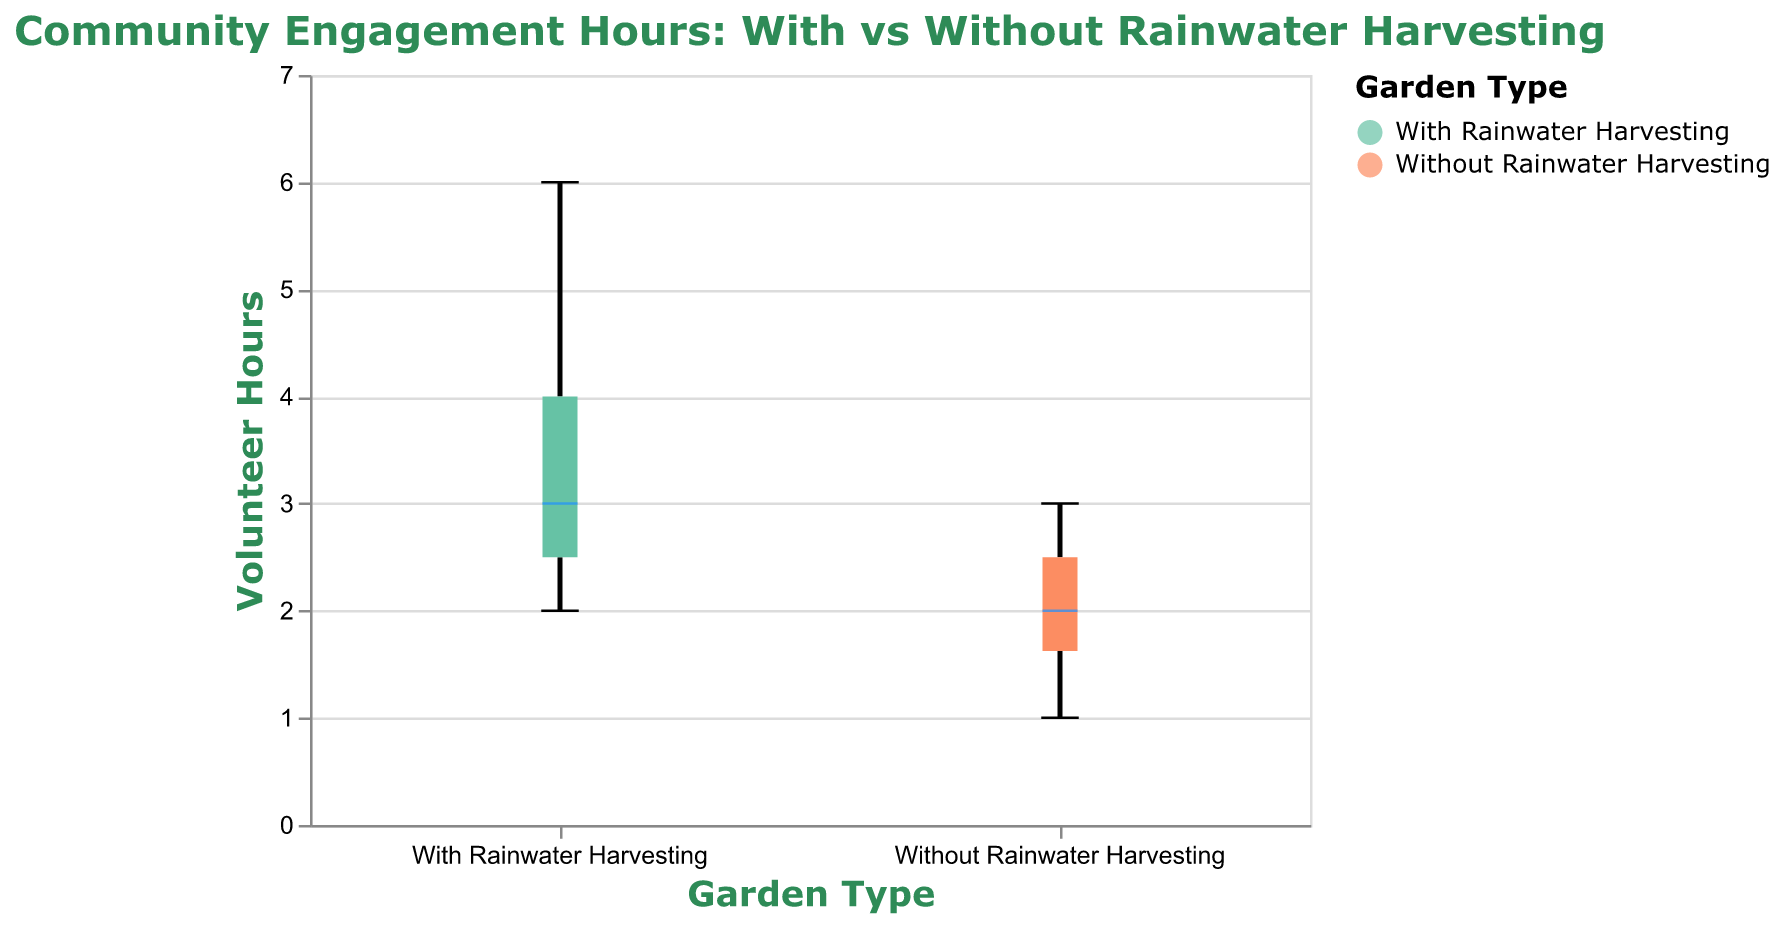What's the title of the figure? The title of the figure is displayed at the top and reads "Community Engagement Hours: With vs Without Rainwater Harvesting".
Answer: Community Engagement Hours: With vs Without Rainwater Harvesting What is the range of volunteer hours plotted on the y-axis? The y-axis limits are indicated with numerical values, with a minimum at 0 and a maximum at 7 hours.
Answer: 0 to 7 hours What is the median volunteer hours for gardens with rainwater harvesting? The median value is represented by a colored line within the box for the group "With Rainwater Harvesting". The median line intersects at approximately 3 hours.
Answer: 3 hours Which garden type shows a higher maximum engagement hours? The boxplot representing the group "With Rainwater Harvesting" extends higher on the y-axis, indicating a greater maximum value compared to the "Without Rainwater Harvesting" group.
Answer: With Rainwater Harvesting What is the interquartile range (IQR) for gardens without rainwater harvesting? For gardens without rainwater harvesting, the IQR is the length of the box between the 25th percentile (lower hinge of the box) and the 75th percentile (upper hinge of the box). Estimating from the plot, the IQR spans from about 1.5 to 3 hours.
Answer: 1.5 to 3 hours Compare the median volunteer hours between the two types of gardens. The median for the "With Rainwater Harvesting" group is 3 hours, whereas the median for the "Without Rainwater Harvesting" group is approximately 2 hours. Hence, gardens with rainwater harvesting have a higher median volunteer engagement.
Answer: Gardens with rainwater harvesting have a higher median What is the maximum recorded engagement hour for gardens without rainwater harvesting? The maximum value for the group "Without Rainwater Harvesting" is indicated by the upper whisker, reaching approximately 3 hours.
Answer: 3 hours Are there any outliers in either group? Both the "With Rainwater Harvesting" and "Without Rainwater Harvesting" groups do not show individual points that would represent outliers beyond the whiskers. Therefore, there are no visible outliers in either group.
Answer: No Which group appears to have a more consistent range of volunteer hours? The "Without Rainwater Harvesting" group has a smaller range (approximately 1 to 3 hours), suggesting more consistency in volunteer hours compared to the "With Rainwater Harvesting" group, which ranges from around 1 to 6 hours.
Answer: Without Rainwater Harvesting 